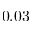<formula> <loc_0><loc_0><loc_500><loc_500>0 . 0 3</formula> 